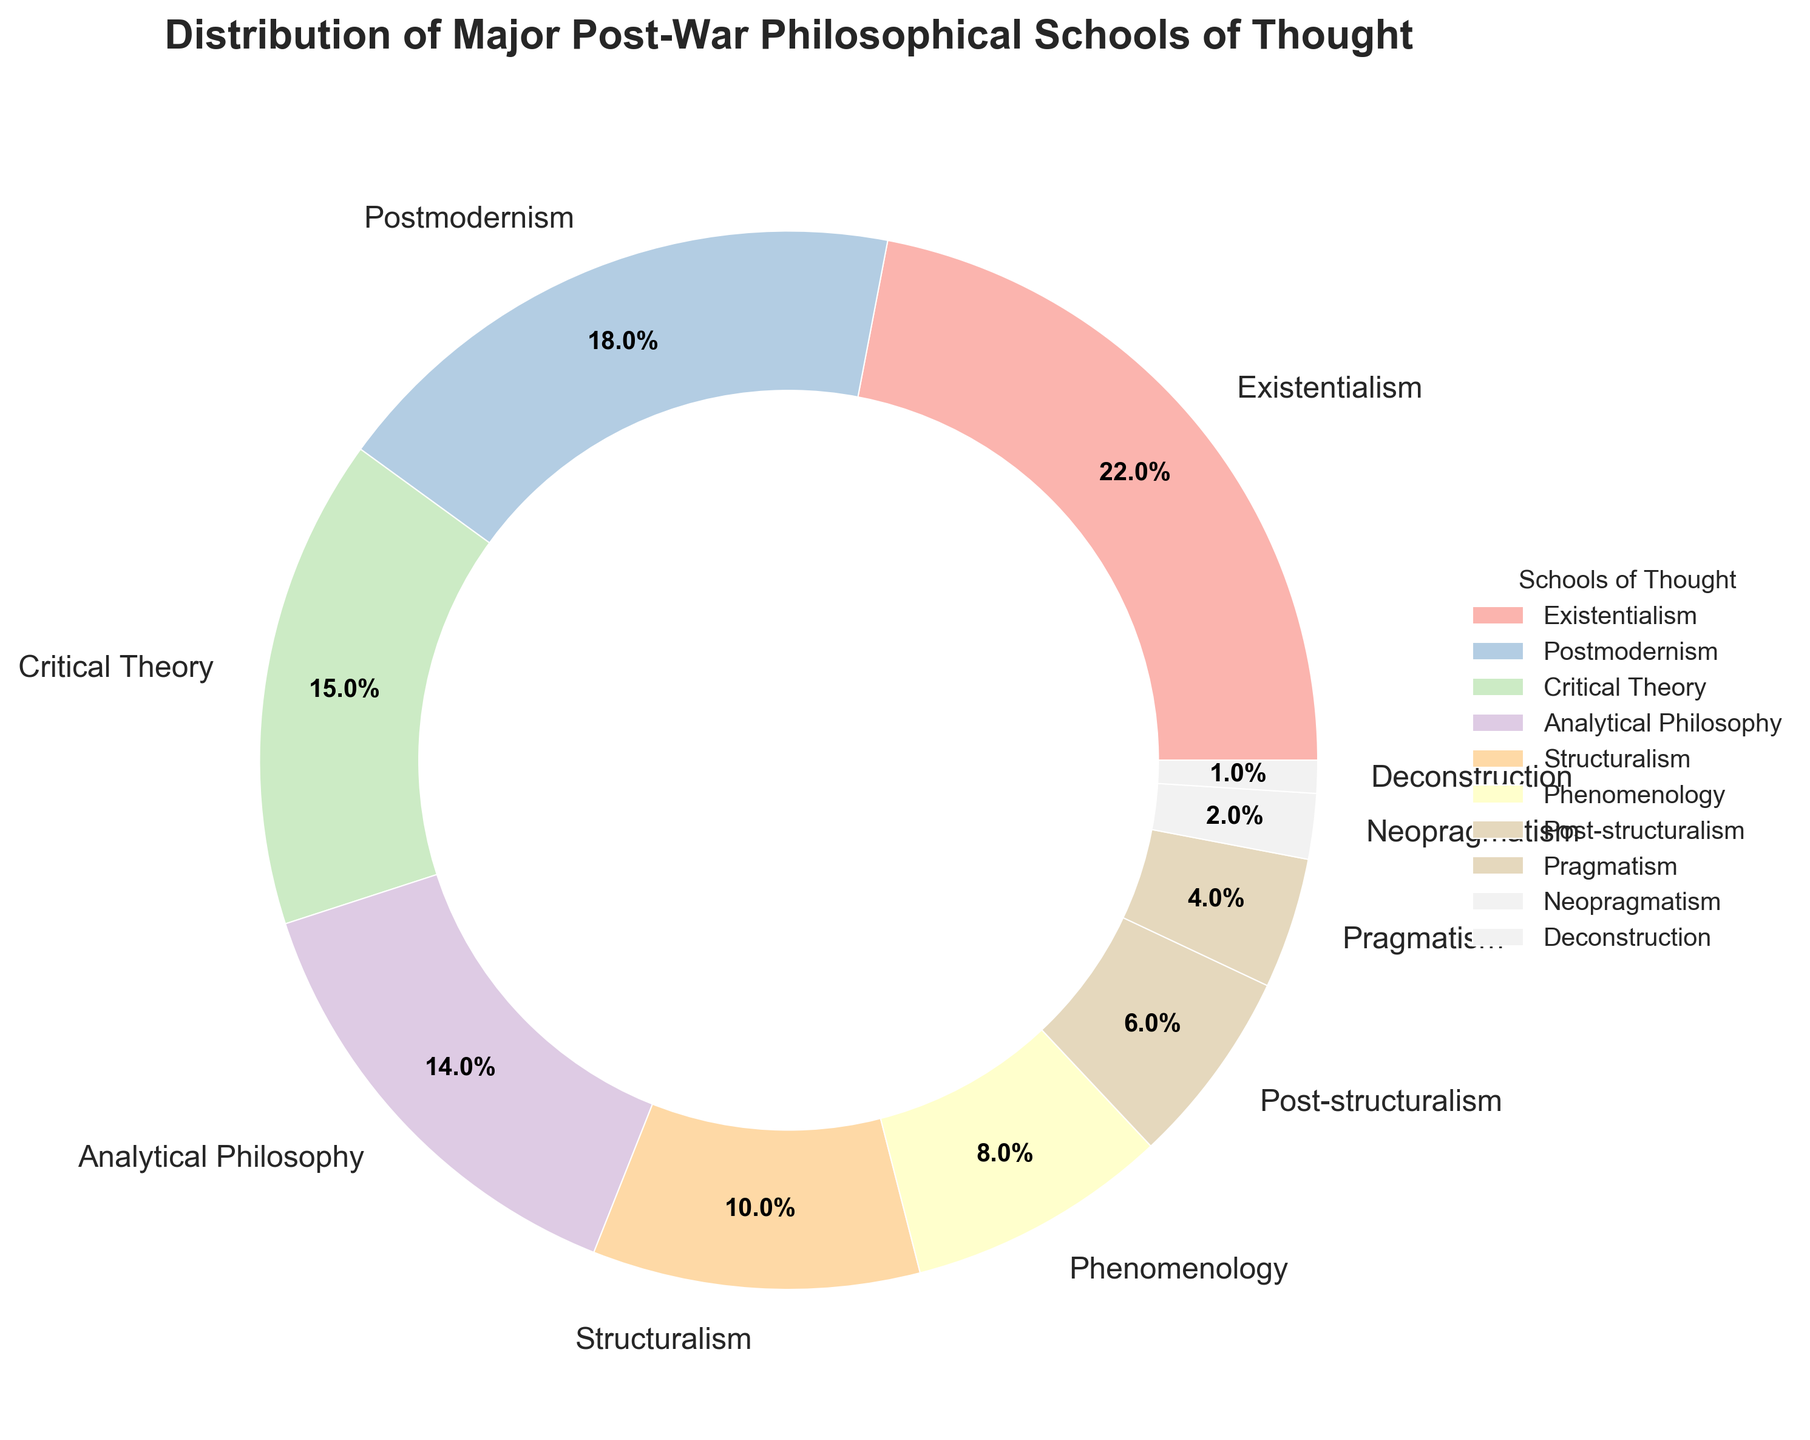Which school of thought occupies the largest portion of the pie chart? Existentialism takes up the largest portion of the pie chart. By observing the chart sections, Existentialism is seen to have the biggest wedge.
Answer: Existentialism What is the combined percentage of Existentialism and Phenomenology? We need to add the percentages of Existentialism (22%) and Phenomenology (8%). This means 22% + 8% = 30%.
Answer: 30% Is Postmodernism more prominent than Analytical Philosophy? Yes, by comparing the percentages, Postmodernism is 18% while Analytical Philosophy is 14%. Therefore, Postmodernism is more prominent.
Answer: Yes How much smaller is the share of Pragmatism compared to Critical Theory? We subtract the percentage of Pragmatism (4%) from that of Critical Theory (15%). So, 15% - 4% = 11%.
Answer: 11% Rank the schools of thought in descending order based on their percentages. By comparing the percentages, the ranking from highest to lowest is: Existentialism (22%), Postmodernism (18%), Critical Theory (15%), Analytical Philosophy (14%), Structuralism (10%), Phenomenology (8%), Post-structuralism (6%), Pragmatism (4%), Neopragmatism (2%), Deconstruction (1%).
Answer: Existentialism > Postmodernism > Critical Theory > Analytical Philosophy > Structuralism > Phenomenology > Post-structuralism > Pragmatism > Neopragmatism > Deconstruction Which three schools of thought collectively make up less than 10% of the total? We note the percentages of Neopragmatism (2%) and Deconstruction (1%), making a subtotal of 3%. Including Post-structuralism (6%), their combined total becomes 9%. Thus, they make up less than 10% of the total.
Answer: Neopragmatism, Deconstruction, and Post-structuralism What is the percentage difference between Structuralism and Post-structuralism? We subtract the percentage of Post-structuralism (6%) from that of Structuralism (10%). So, 10% - 6% = 4%.
Answer: 4% Are there more schools of thought with a share above 10% or below 10%? Count the schools above 10% (Existentialism, Postmodernism, Critical Theory, Analytical Philosophy) which total 4, and those below 10% (Structuralism, Phenomenology, Post-structuralism, Pragmatism, Neopragmatism, Deconstruction) which total 6. Therefore, there are more schools below 10%.
Answer: Below 10% What is the smallest school of thought represented in the pie chart? Deconstruction occupies the smallest portion, with just 1% of the total chart.
Answer: Deconstruction What is the average percentage of the top 4 schools of thought by share? We need to sum the top 4 percentages and divide by 4: (22% Existentialism + 18% Postmodernism + 15% Critical Theory + 14% Analytical Philosophy) / 4 = 69% / 4 = 17.25%.
Answer: 17.25% 